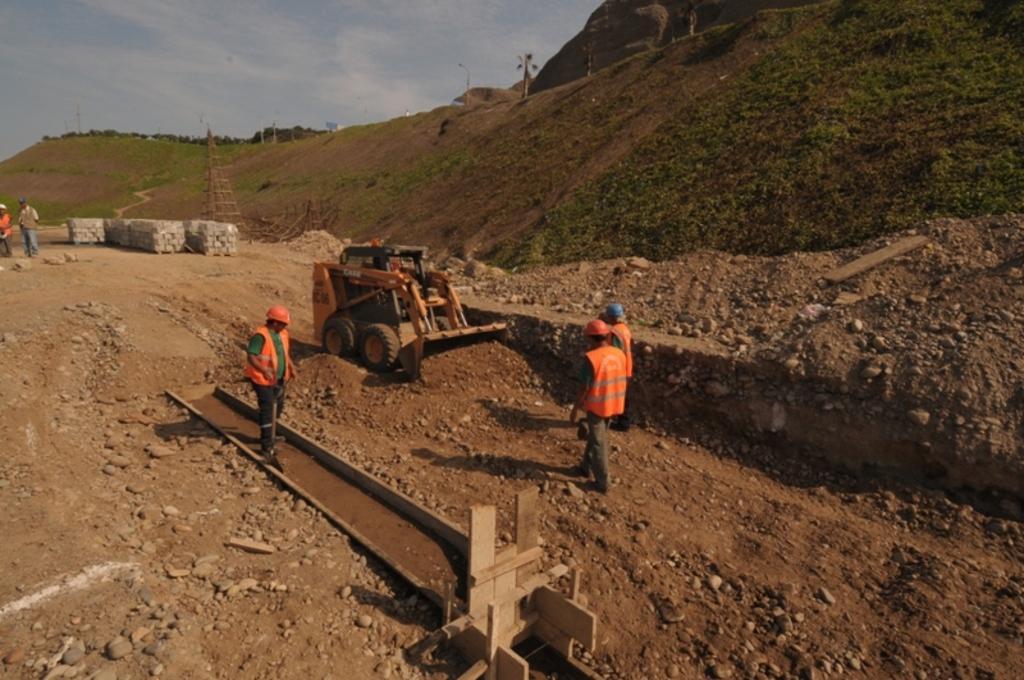How would you summarize this image in a sentence or two? There are people, an object and a vehicle in the foreground area of the image, it seems like mountains, a tower, poles, people and the sky in the background. 